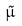<formula> <loc_0><loc_0><loc_500><loc_500>\tilde { \mu }</formula> 